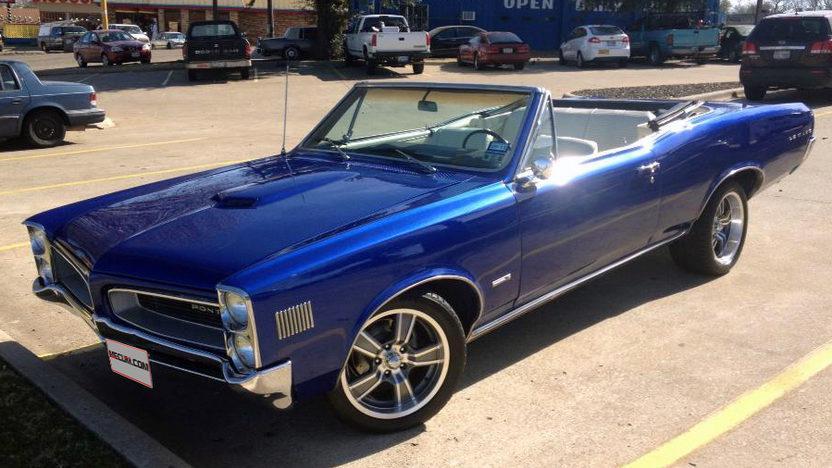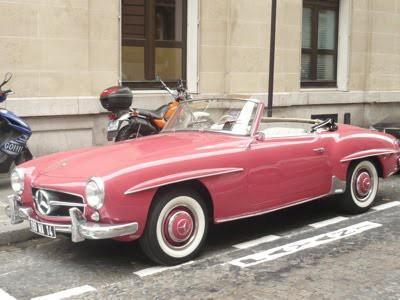The first image is the image on the left, the second image is the image on the right. Evaluate the accuracy of this statement regarding the images: "At least one vehicle is not red or pink.". Is it true? Answer yes or no. Yes. 